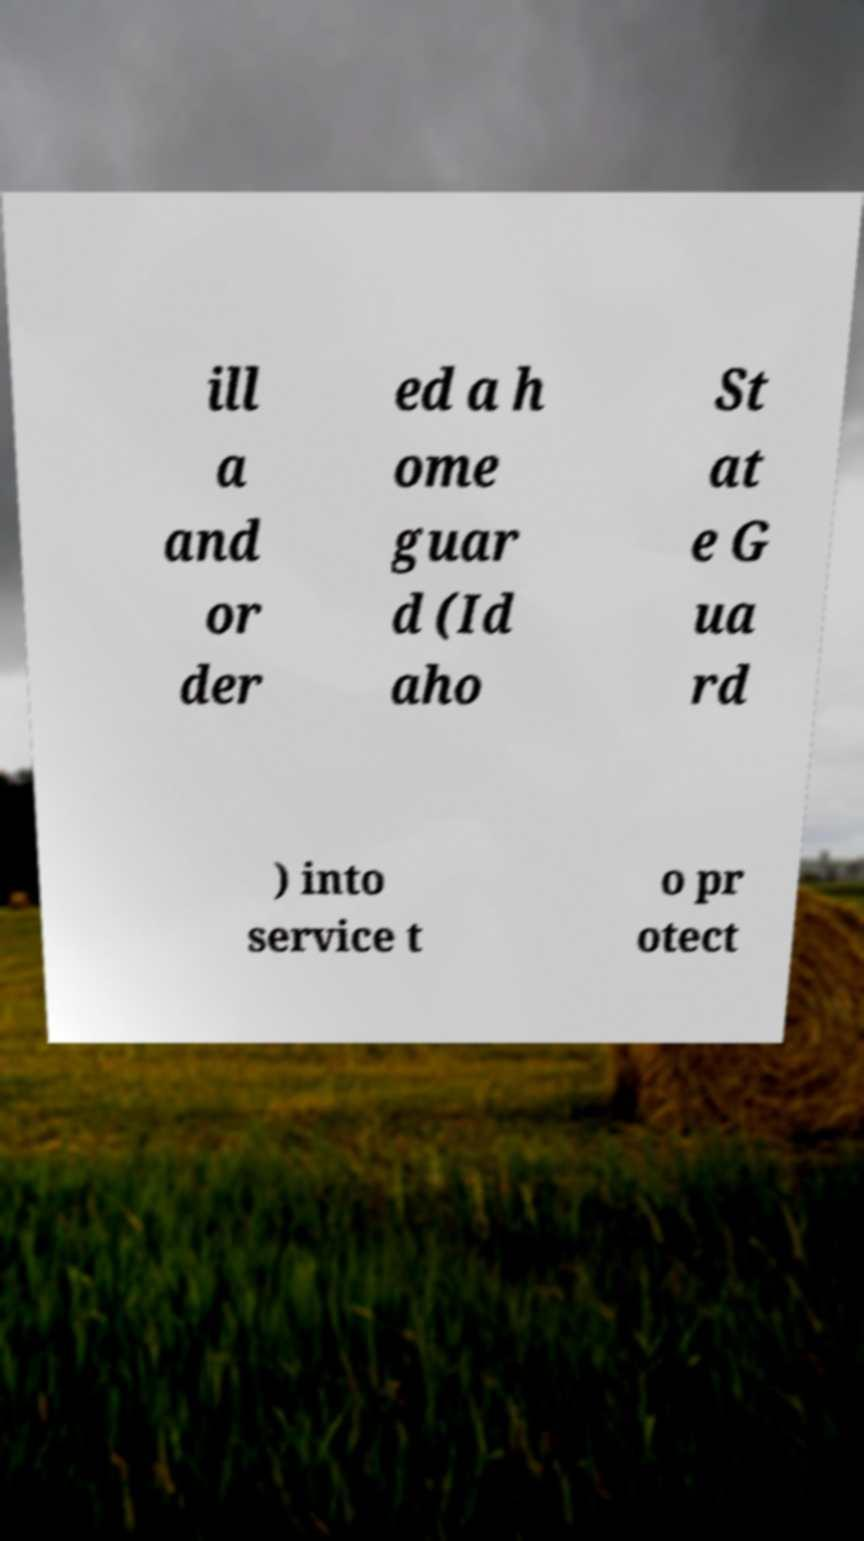For documentation purposes, I need the text within this image transcribed. Could you provide that? ill a and or der ed a h ome guar d (Id aho St at e G ua rd ) into service t o pr otect 